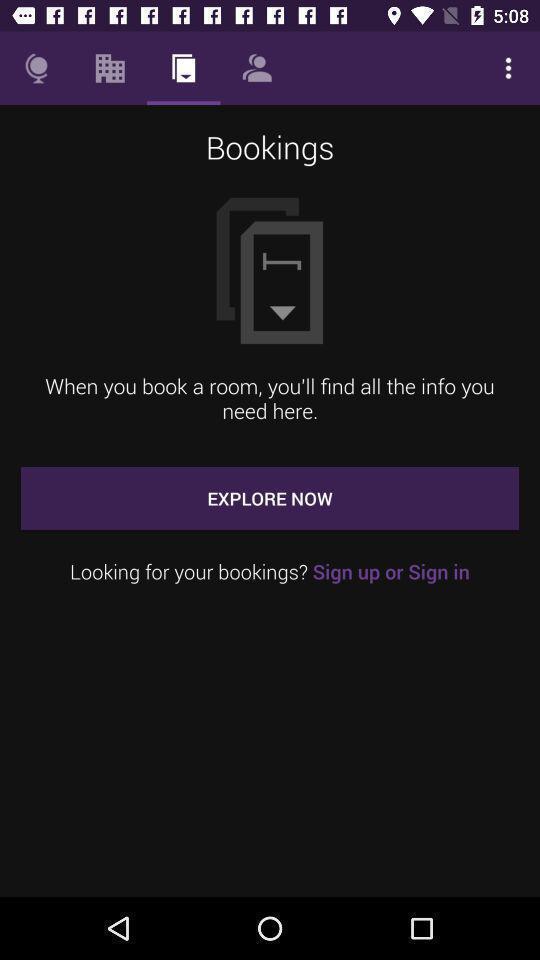Please provide a description for this image. Screen showing bookings page. 